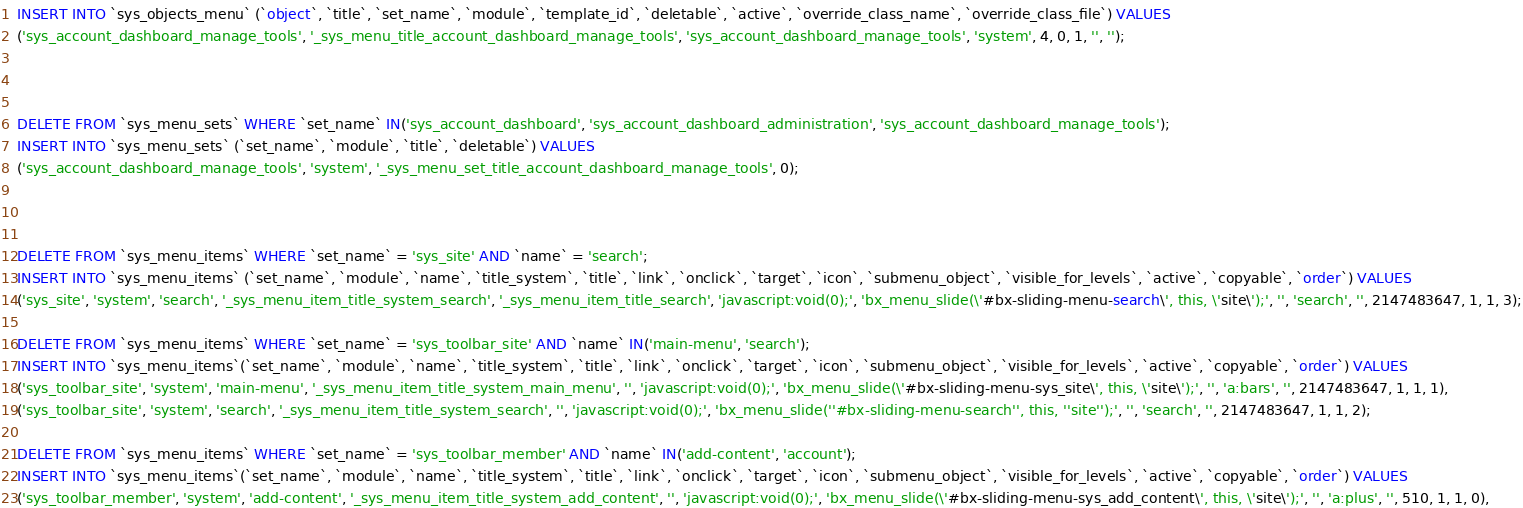<code> <loc_0><loc_0><loc_500><loc_500><_SQL_>INSERT INTO `sys_objects_menu` (`object`, `title`, `set_name`, `module`, `template_id`, `deletable`, `active`, `override_class_name`, `override_class_file`) VALUES
('sys_account_dashboard_manage_tools', '_sys_menu_title_account_dashboard_manage_tools', 'sys_account_dashboard_manage_tools', 'system', 4, 0, 1, '', '');



DELETE FROM `sys_menu_sets` WHERE `set_name` IN('sys_account_dashboard', 'sys_account_dashboard_administration', 'sys_account_dashboard_manage_tools');
INSERT INTO `sys_menu_sets` (`set_name`, `module`, `title`, `deletable`) VALUES
('sys_account_dashboard_manage_tools', 'system', '_sys_menu_set_title_account_dashboard_manage_tools', 0);



DELETE FROM `sys_menu_items` WHERE `set_name` = 'sys_site' AND `name` = 'search';
INSERT INTO `sys_menu_items` (`set_name`, `module`, `name`, `title_system`, `title`, `link`, `onclick`, `target`, `icon`, `submenu_object`, `visible_for_levels`, `active`, `copyable`, `order`) VALUES
('sys_site', 'system', 'search', '_sys_menu_item_title_system_search', '_sys_menu_item_title_search', 'javascript:void(0);', 'bx_menu_slide(\'#bx-sliding-menu-search\', this, \'site\');', '', 'search', '', 2147483647, 1, 1, 3);

DELETE FROM `sys_menu_items` WHERE `set_name` = 'sys_toolbar_site' AND `name` IN('main-menu', 'search');
INSERT INTO `sys_menu_items`(`set_name`, `module`, `name`, `title_system`, `title`, `link`, `onclick`, `target`, `icon`, `submenu_object`, `visible_for_levels`, `active`, `copyable`, `order`) VALUES 
('sys_toolbar_site', 'system', 'main-menu', '_sys_menu_item_title_system_main_menu', '', 'javascript:void(0);', 'bx_menu_slide(\'#bx-sliding-menu-sys_site\', this, \'site\');', '', 'a:bars', '', 2147483647, 1, 1, 1),
('sys_toolbar_site', 'system', 'search', '_sys_menu_item_title_system_search', '', 'javascript:void(0);', 'bx_menu_slide(''#bx-sliding-menu-search'', this, ''site'');', '', 'search', '', 2147483647, 1, 1, 2);

DELETE FROM `sys_menu_items` WHERE `set_name` = 'sys_toolbar_member' AND `name` IN('add-content', 'account');
INSERT INTO `sys_menu_items`(`set_name`, `module`, `name`, `title_system`, `title`, `link`, `onclick`, `target`, `icon`, `submenu_object`, `visible_for_levels`, `active`, `copyable`, `order`) VALUES 
('sys_toolbar_member', 'system', 'add-content', '_sys_menu_item_title_system_add_content', '', 'javascript:void(0);', 'bx_menu_slide(\'#bx-sliding-menu-sys_add_content\', this, \'site\');', '', 'a:plus', '', 510, 1, 1, 0),</code> 